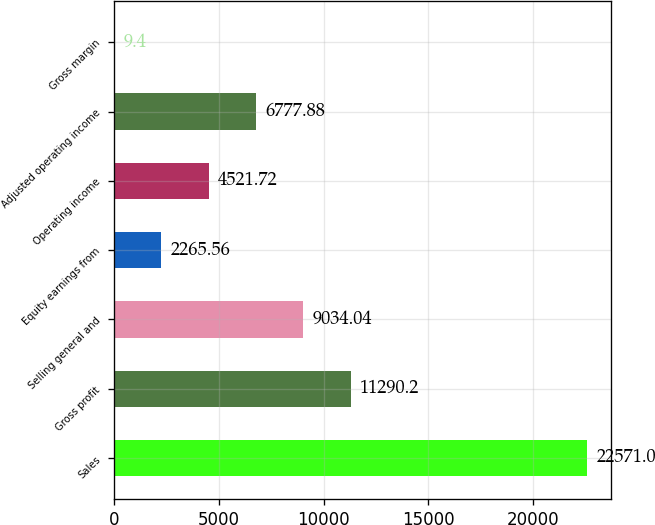Convert chart. <chart><loc_0><loc_0><loc_500><loc_500><bar_chart><fcel>Sales<fcel>Gross profit<fcel>Selling general and<fcel>Equity earnings from<fcel>Operating income<fcel>Adjusted operating income<fcel>Gross margin<nl><fcel>22571<fcel>11290.2<fcel>9034.04<fcel>2265.56<fcel>4521.72<fcel>6777.88<fcel>9.4<nl></chart> 